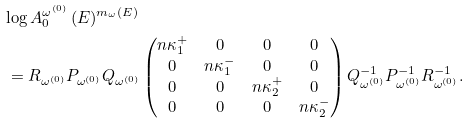Convert formula to latex. <formula><loc_0><loc_0><loc_500><loc_500>& \log A _ { 0 } ^ { \omega ^ { ( 0 ) } } \, ( E ) ^ { m _ { \omega } ( E ) } \\ & \, = R _ { \omega ^ { ( 0 ) } } P _ { \omega ^ { ( 0 ) } } Q _ { \omega ^ { ( 0 ) } } \begin{pmatrix} \L n \kappa _ { 1 } ^ { + } & 0 & 0 & 0 \\ 0 & \L n \kappa _ { 1 } ^ { - } & 0 & 0 \\ 0 & 0 & \L n \kappa _ { 2 } ^ { + } & 0 \\ 0 & 0 & 0 & \L n \kappa _ { 2 } ^ { - } \end{pmatrix} Q _ { \omega ^ { ( 0 ) } } ^ { - 1 } P _ { \omega ^ { ( 0 ) } } ^ { - 1 } R _ { \omega ^ { ( 0 ) } } ^ { - 1 } .</formula> 